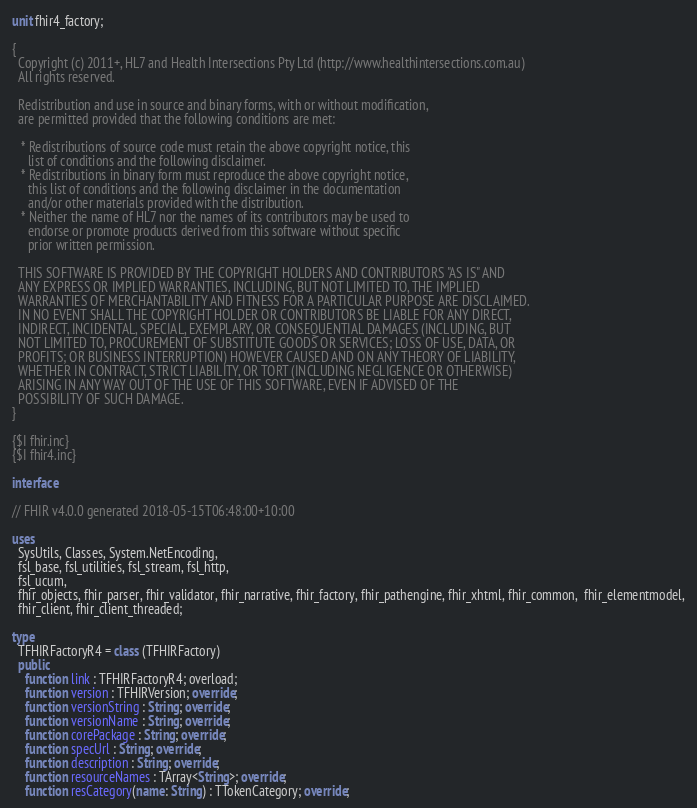<code> <loc_0><loc_0><loc_500><loc_500><_Pascal_>unit fhir4_factory;

{
  Copyright (c) 2011+, HL7 and Health Intersections Pty Ltd (http://www.healthintersections.com.au)
  All rights reserved.

  Redistribution and use in source and binary forms, with or without modification,
  are permitted provided that the following conditions are met:

   * Redistributions of source code must retain the above copyright notice, this
     list of conditions and the following disclaimer.
   * Redistributions in binary form must reproduce the above copyright notice,
     this list of conditions and the following disclaimer in the documentation
     and/or other materials provided with the distribution.
   * Neither the name of HL7 nor the names of its contributors may be used to
     endorse or promote products derived from this software without specific
     prior written permission.

  THIS SOFTWARE IS PROVIDED BY THE COPYRIGHT HOLDERS AND CONTRIBUTORS "AS IS" AND
  ANY EXPRESS OR IMPLIED WARRANTIES, INCLUDING, BUT NOT LIMITED TO, THE IMPLIED
  WARRANTIES OF MERCHANTABILITY AND FITNESS FOR A PARTICULAR PURPOSE ARE DISCLAIMED.
  IN NO EVENT SHALL THE COPYRIGHT HOLDER OR CONTRIBUTORS BE LIABLE FOR ANY DIRECT,
  INDIRECT, INCIDENTAL, SPECIAL, EXEMPLARY, OR CONSEQUENTIAL DAMAGES (INCLUDING, BUT
  NOT LIMITED TO, PROCUREMENT OF SUBSTITUTE GOODS OR SERVICES; LOSS OF USE, DATA, OR
  PROFITS; OR BUSINESS INTERRUPTION) HOWEVER CAUSED AND ON ANY THEORY OF LIABILITY,
  WHETHER IN CONTRACT, STRICT LIABILITY, OR TORT (INCLUDING NEGLIGENCE OR OTHERWISE)
  ARISING IN ANY WAY OUT OF THE USE OF THIS SOFTWARE, EVEN IF ADVISED OF THE
  POSSIBILITY OF SUCH DAMAGE.
}

{$I fhir.inc}
{$I fhir4.inc}

interface

// FHIR v4.0.0 generated 2018-05-15T06:48:00+10:00

uses
  SysUtils, Classes, System.NetEncoding,
  fsl_base, fsl_utilities, fsl_stream, fsl_http,
  fsl_ucum,
  fhir_objects, fhir_parser, fhir_validator, fhir_narrative, fhir_factory, fhir_pathengine, fhir_xhtml, fhir_common,  fhir_elementmodel,
  fhir_client, fhir_client_threaded;

type
  TFHIRFactoryR4 = class (TFHIRFactory)
  public
    function link : TFHIRFactoryR4; overload;
    function version : TFHIRVersion; override;
    function versionString : String; override;
    function versionName : String; override;
    function corePackage : String; override;
    function specUrl : String; override;
    function description : String; override;
    function resourceNames : TArray<String>; override;
    function resCategory(name: String) : TTokenCategory; override;</code> 